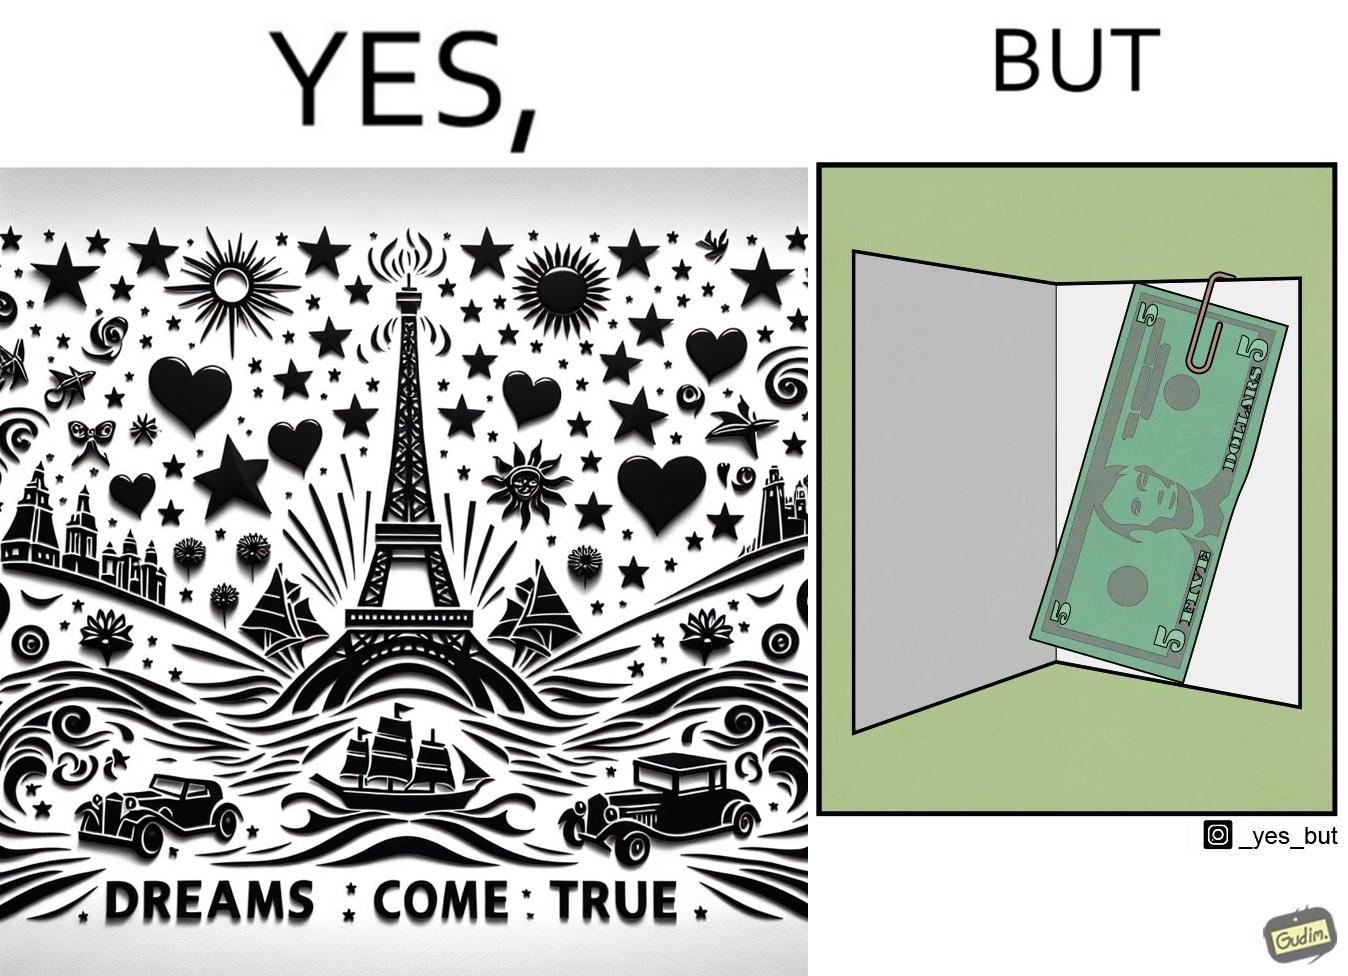What is the satirical meaning behind this image? The overall image is funny because while the front of the card gives hope that the person receiving this card will have one of their dreams come true but opening the card reveals only 5 dollars which is nowhere enough to fulfil any kind of dream. 